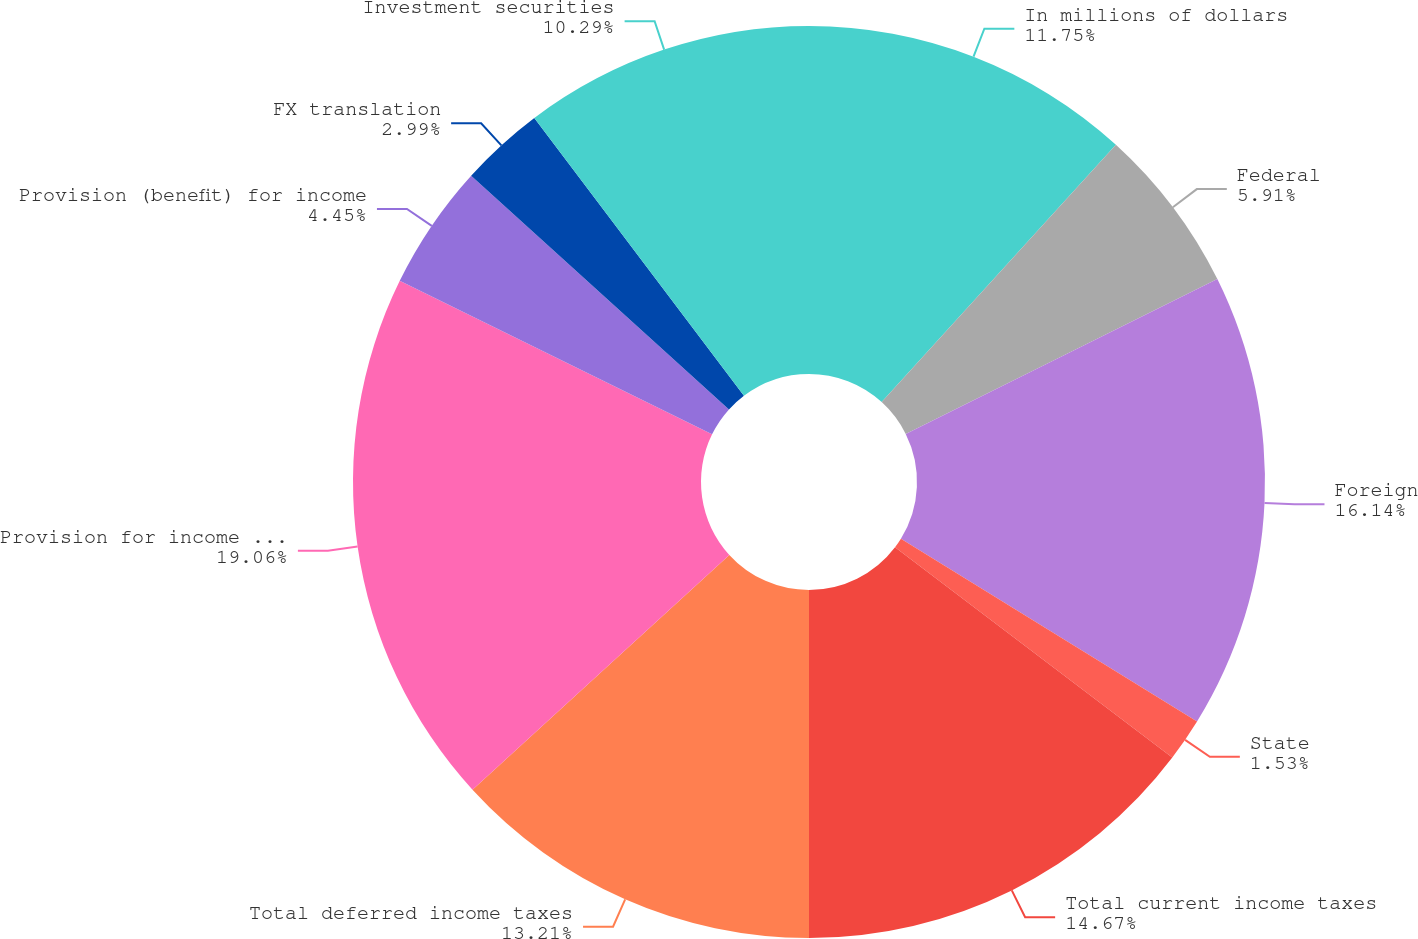Convert chart. <chart><loc_0><loc_0><loc_500><loc_500><pie_chart><fcel>In millions of dollars<fcel>Federal<fcel>Foreign<fcel>State<fcel>Total current income taxes<fcel>Total deferred income taxes<fcel>Provision for income tax on<fcel>Provision (benefit) for income<fcel>FX translation<fcel>Investment securities<nl><fcel>11.75%<fcel>5.91%<fcel>16.14%<fcel>1.53%<fcel>14.67%<fcel>13.21%<fcel>19.06%<fcel>4.45%<fcel>2.99%<fcel>10.29%<nl></chart> 